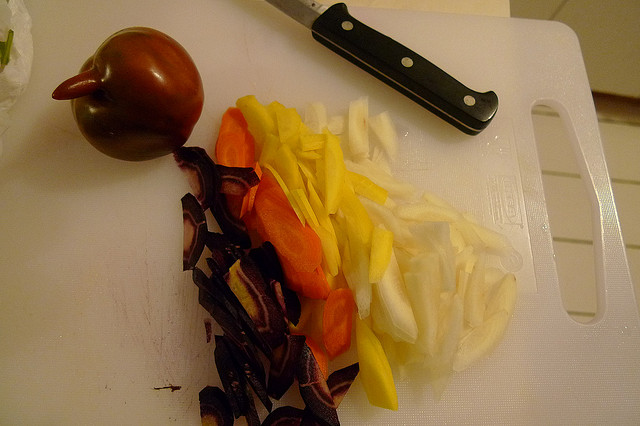<image>Which fruit is the knife slicing into? It is not possible to determine which fruit the knife is slicing into. It could be an apple, a mango, an onion, or a pepper. Which fruit is the knife slicing into? I am not sure which fruit the knife is slicing into. It can be apple, mango or pepper. 